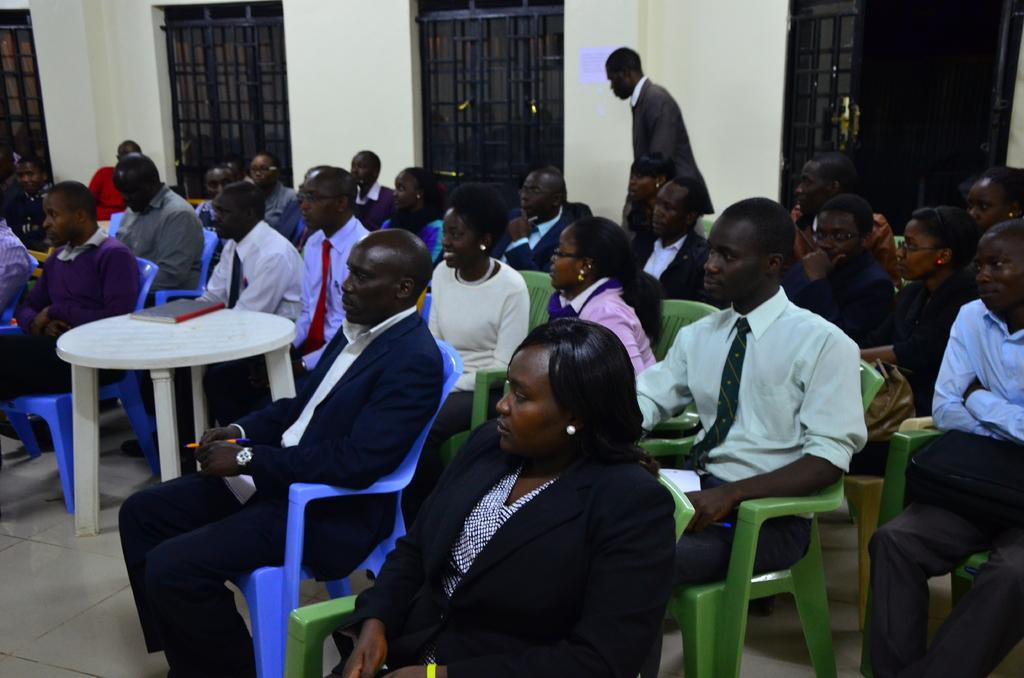What type of structures can be seen in the image? There are grilles and walls in the image. Are there any people present in the image? Yes, there are people in the image. What is on the table in the image? There is a book on the table in the image. What type of flooring is visible in the image? There is tile floor in the image. Can you describe any objects in the image? Yes, there are objects in the image. What is the position of one of the people in the image? One person is standing in the image. Is there any decoration on the walls in the image? Yes, there is a poster on a wall in the image. How many geese are flying over the grilles in the image? There are no geese present in the image; it only features grilles, walls, people, a table, a book, tile floor, and a poster on a wall. 